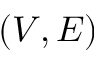Convert formula to latex. <formula><loc_0><loc_0><loc_500><loc_500>( V , E )</formula> 